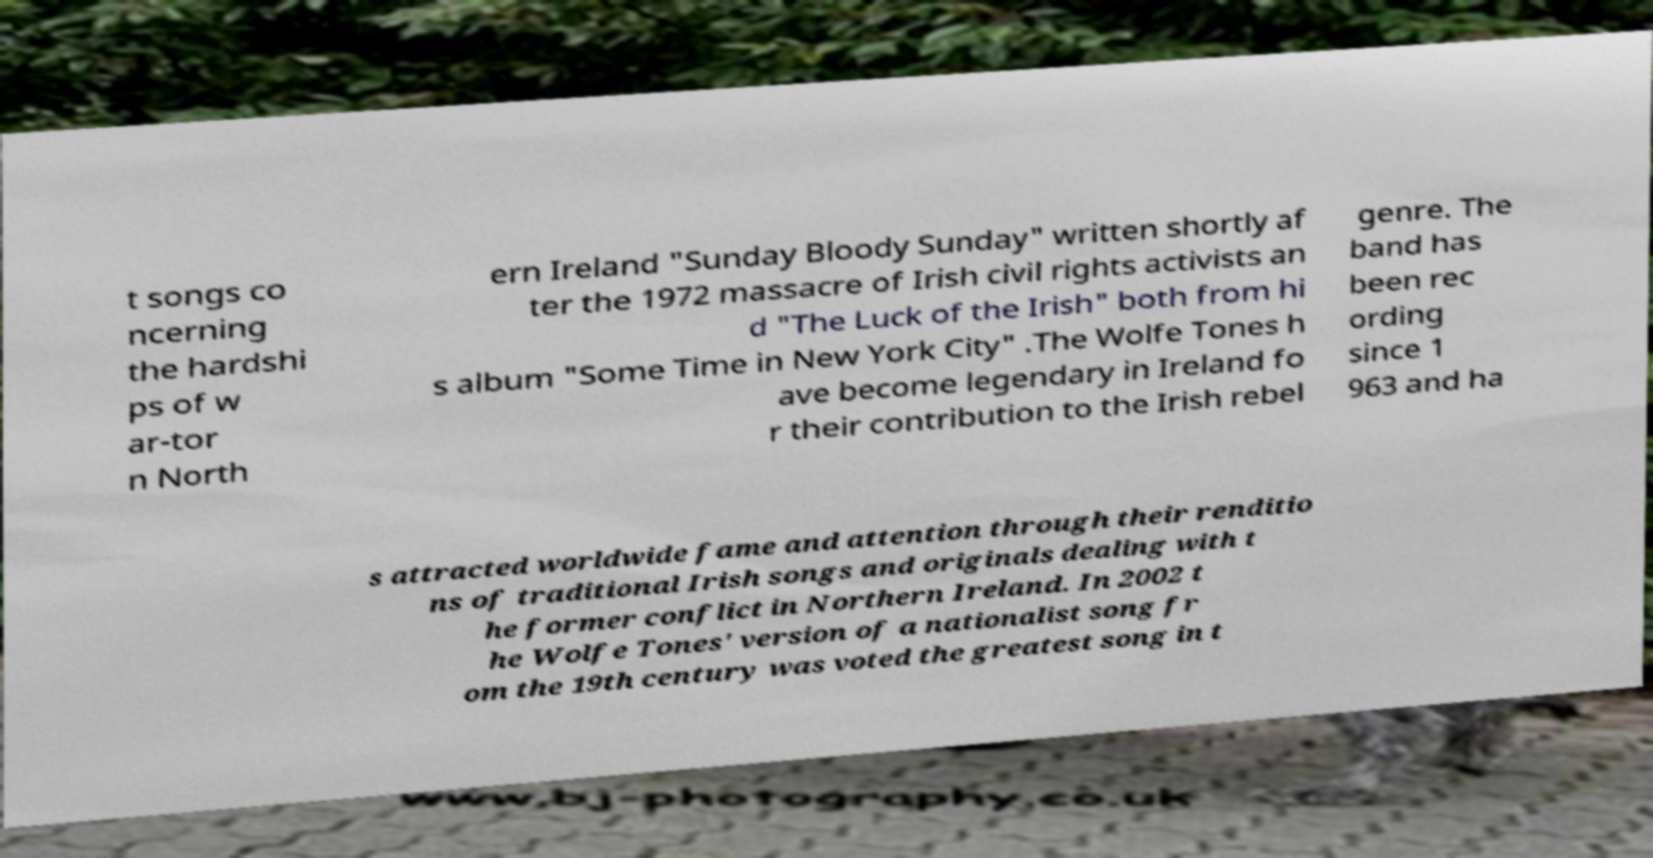What messages or text are displayed in this image? I need them in a readable, typed format. t songs co ncerning the hardshi ps of w ar-tor n North ern Ireland "Sunday Bloody Sunday" written shortly af ter the 1972 massacre of Irish civil rights activists an d "The Luck of the Irish" both from hi s album "Some Time in New York City" .The Wolfe Tones h ave become legendary in Ireland fo r their contribution to the Irish rebel genre. The band has been rec ording since 1 963 and ha s attracted worldwide fame and attention through their renditio ns of traditional Irish songs and originals dealing with t he former conflict in Northern Ireland. In 2002 t he Wolfe Tones' version of a nationalist song fr om the 19th century was voted the greatest song in t 